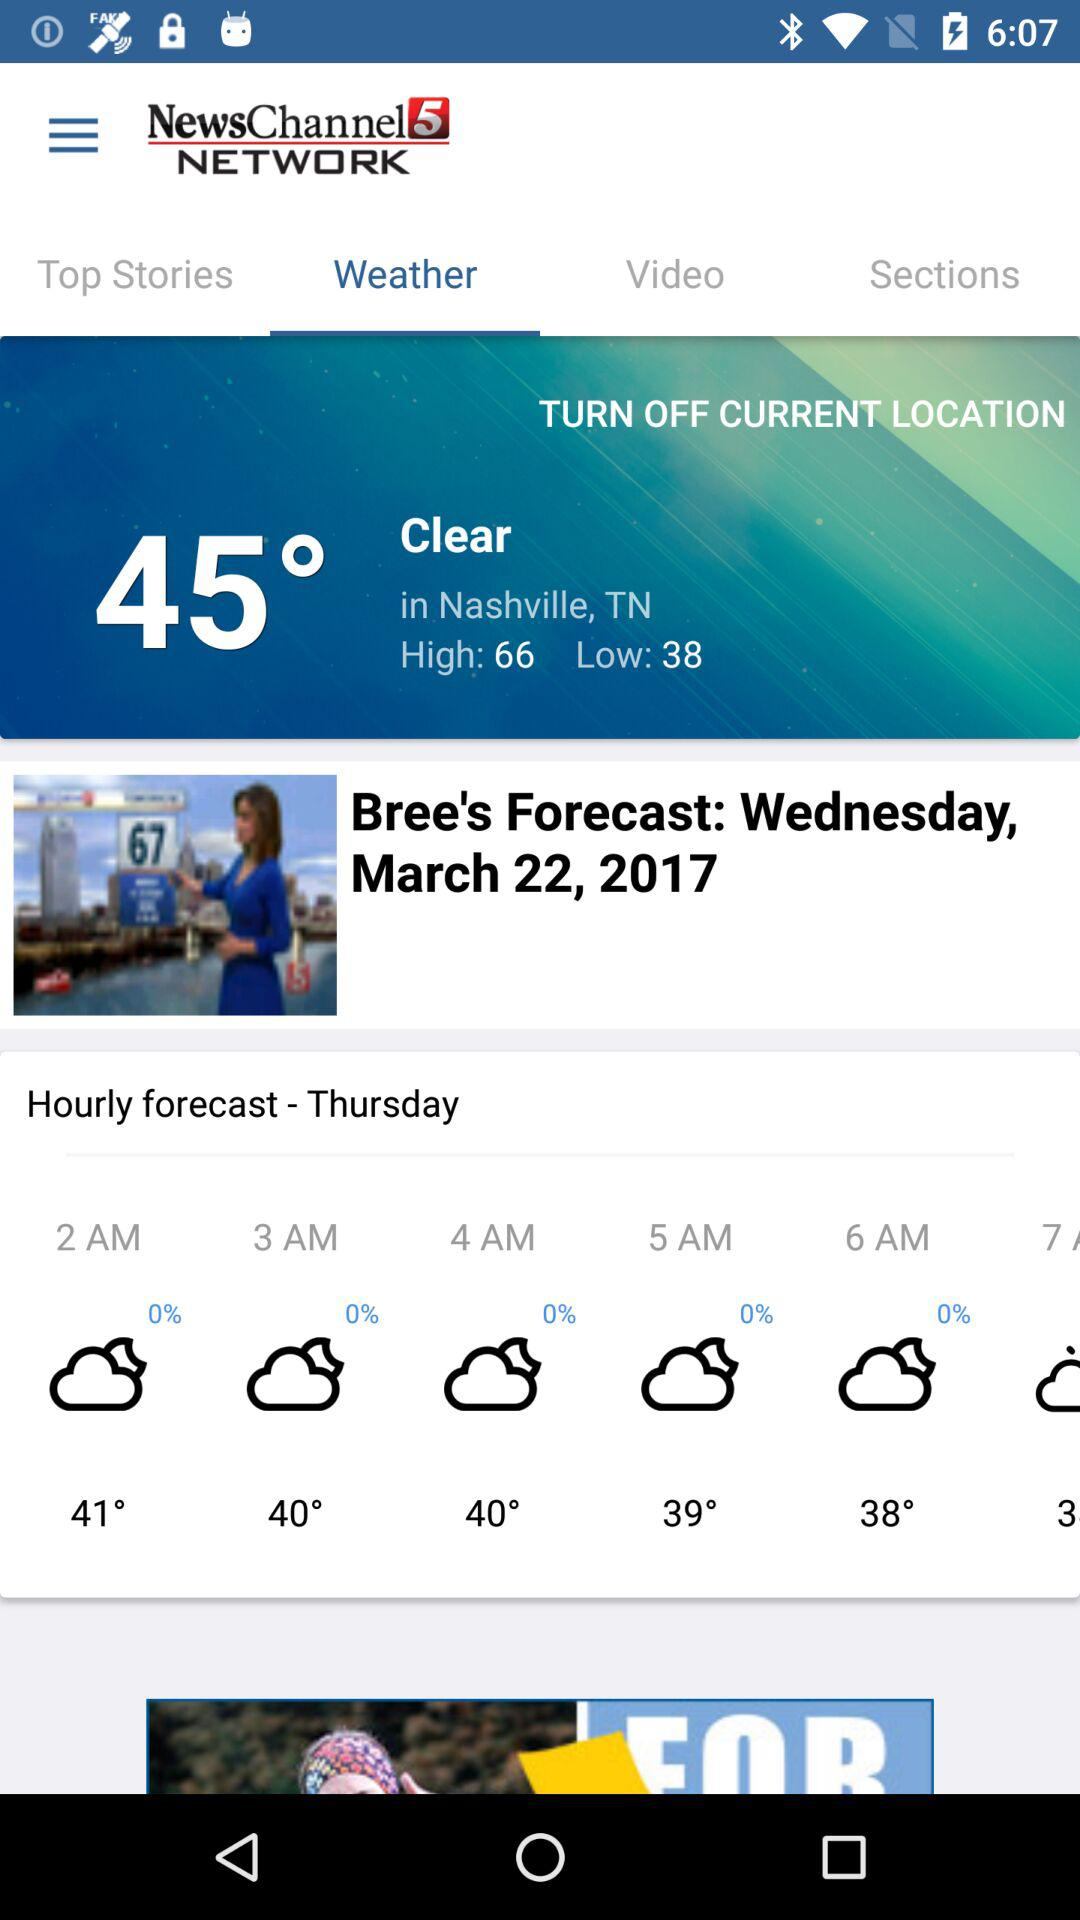What is the temperature? The temperature is 45°. 